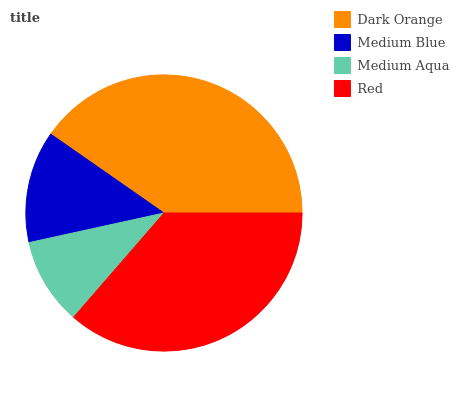Is Medium Aqua the minimum?
Answer yes or no. Yes. Is Dark Orange the maximum?
Answer yes or no. Yes. Is Medium Blue the minimum?
Answer yes or no. No. Is Medium Blue the maximum?
Answer yes or no. No. Is Dark Orange greater than Medium Blue?
Answer yes or no. Yes. Is Medium Blue less than Dark Orange?
Answer yes or no. Yes. Is Medium Blue greater than Dark Orange?
Answer yes or no. No. Is Dark Orange less than Medium Blue?
Answer yes or no. No. Is Red the high median?
Answer yes or no. Yes. Is Medium Blue the low median?
Answer yes or no. Yes. Is Medium Aqua the high median?
Answer yes or no. No. Is Medium Aqua the low median?
Answer yes or no. No. 